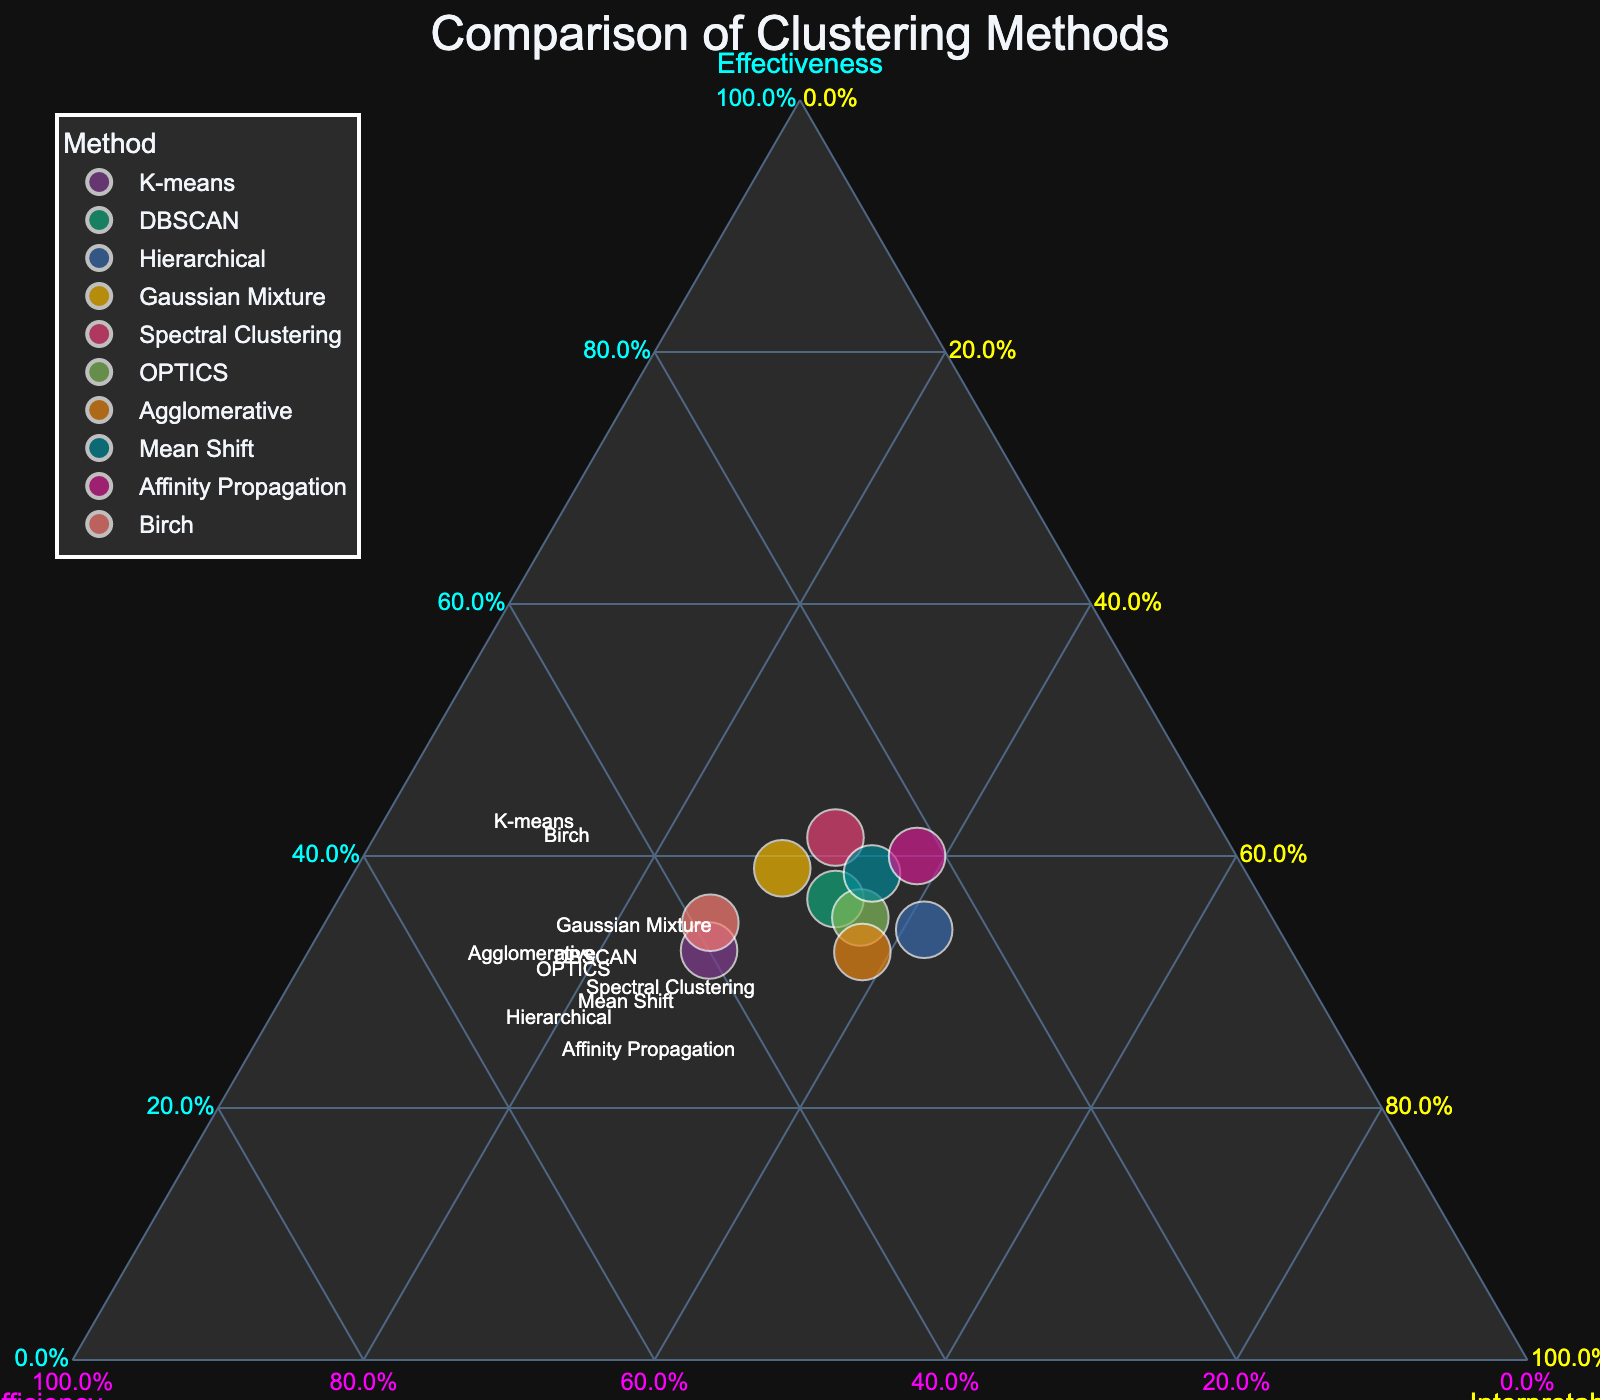What is the title of the figure? The title of the figure is typically found at the top and is clearly displayed. In this case, it reads "Comparison of Clustering Methods."
Answer: Comparison of Clustering Methods How many clustering methods are compared in the figure? Each clustering method is represented by a distinct data point on the figure. Counting these points gives us the number of methods compared.
Answer: 10 Which axis corresponds to Effectiveness, and what is its color? The axes are labeled with their corresponding criteria and colors. The axis corresponding to Effectiveness is labeled "Effectiveness" and is cyan in color.
Answer: Effectiveness, cyan Which clustering method has the highest interpretability? By locating the data point closest to the vertex labeled "Interpretability," we identify the method with the highest interpretability.
Answer: Hierarchical Among the methods with high effectiveness, which one has the lowest efficiency? Filtering the methods with high effectiveness by looking closely at the effectiveness axis, we then identify the method among them with the lowest efficiency by locating it near the efficiency axis.
Answer: Affinity Propagation Which clustering methods have both high interpretability and high efficiency? By identifying points that are near both the Interpretability and Efficiency vertices, we find the methods that score high in both criteria.
Answer: Agglomerative, OPTICS What is the method with an equal or close balance of effectiveness, efficiency, and interpretability? A point equally distant from all three vertices or at the centroid (center of the triangle) indicates a balanced method. We find the point closest to this centroid.
Answer: K-means Which method is the least computationally efficient according to the plot? By finding the point furthest from the vertex labeled "Efficiency," we determine the least efficient method.
Answer: Affinity Propagation Do higher effectiveness and higher interpretability always correspond to lower efficiency? By examining the placement of methods high on Effectiveness and Interpretability axes and noting their efficiency values, we deduce if this is a common trend or not.
Answer: No How do Birch and Spectral Clustering compare in terms of efficiency? We locate the points for Birch and Spectral Clustering and compare their positions relative to the Efficiency axis to see which has higher efficiency.
Answer: Birch is more efficient 